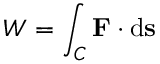<formula> <loc_0><loc_0><loc_500><loc_500>W = \int _ { C } F \cdot d s</formula> 